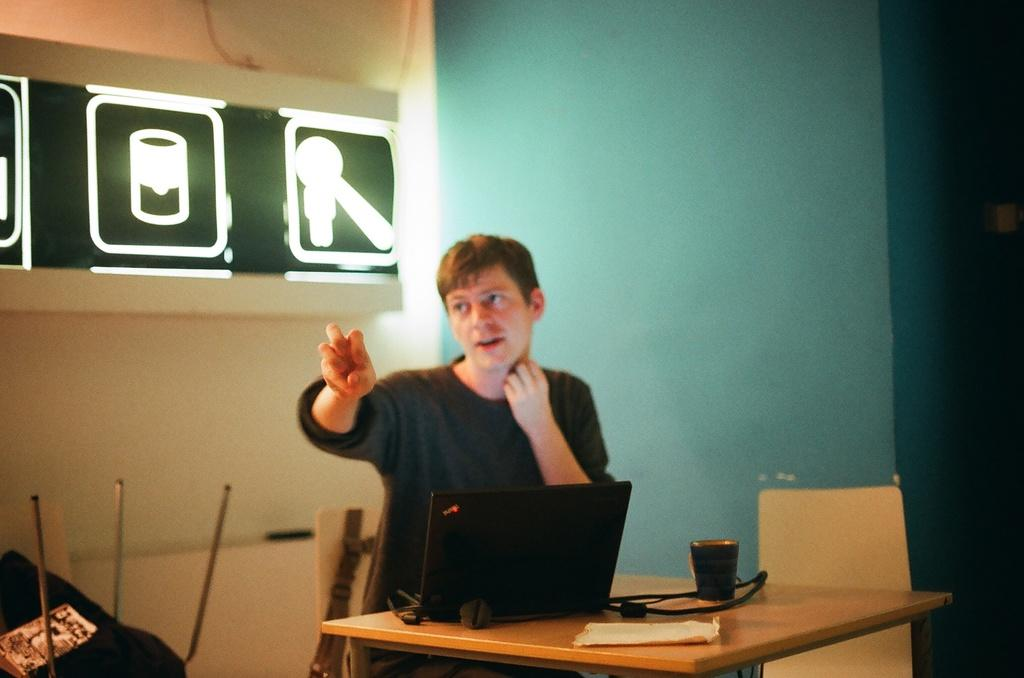What is the man in the image doing? The man is sitting on a chair and raising his hand. What is in front of the man? There is a table in front of the man. What objects are on the table? There is a laptop, a cable, and a cup on the table. What is the scent of the governor's cologne in the image? There is no governor or cologne present in the image. 